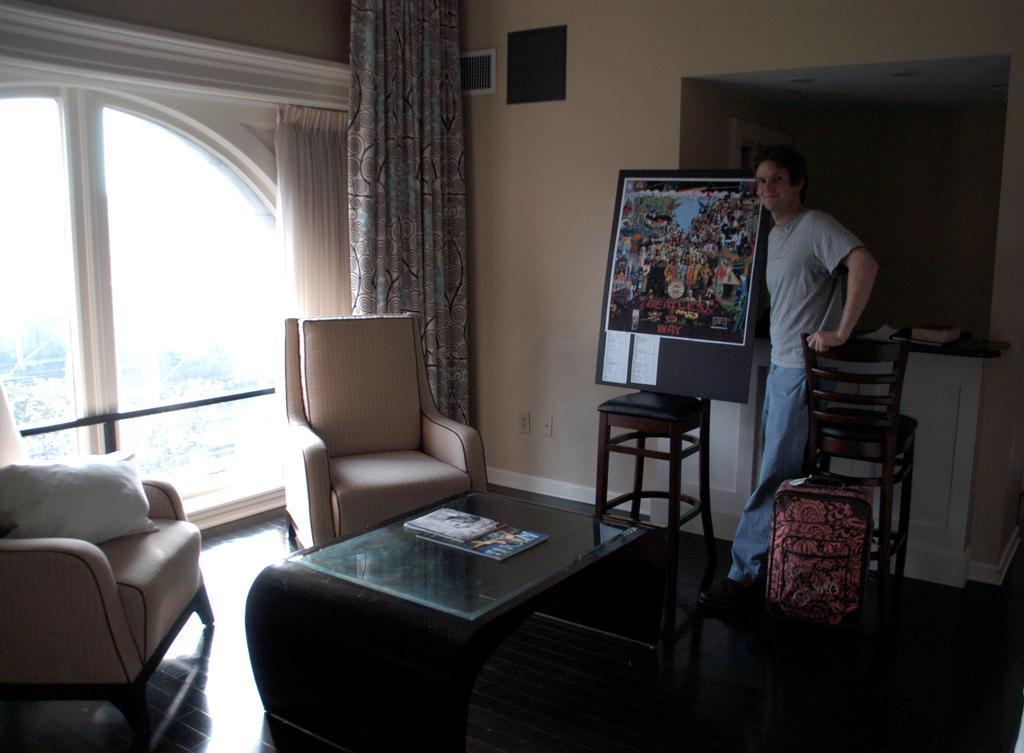Describe this image in one or two sentences. This is a picture taken in a room, the man is standing on the floor. On the left side of the man there is a board and the right side of the man there is a chair and bag. In front of the man there is a table chairs and a glass window and curtains. Background of the man is a wall. 